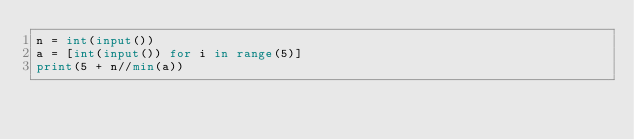<code> <loc_0><loc_0><loc_500><loc_500><_Python_>n = int(input())
a = [int(input()) for i in range(5)]
print(5 + n//min(a))</code> 